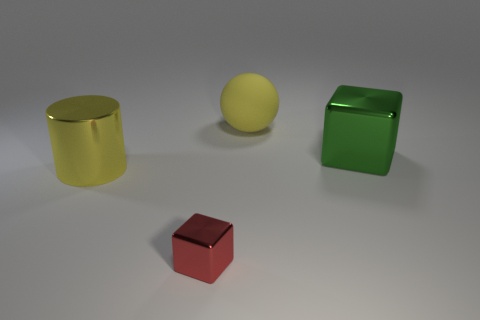Add 1 large yellow matte spheres. How many objects exist? 5 Subtract all balls. How many objects are left? 3 Add 2 matte things. How many matte things exist? 3 Subtract 0 blue blocks. How many objects are left? 4 Subtract all small metallic cubes. Subtract all blue things. How many objects are left? 3 Add 3 big green metallic blocks. How many big green metallic blocks are left? 4 